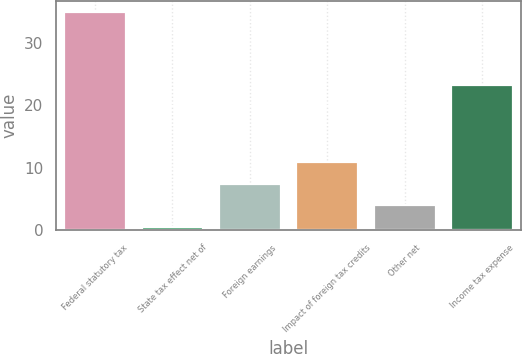<chart> <loc_0><loc_0><loc_500><loc_500><bar_chart><fcel>Federal statutory tax<fcel>State tax effect net of<fcel>Foreign earnings<fcel>Impact of foreign tax credits<fcel>Other net<fcel>Income tax expense<nl><fcel>35<fcel>0.5<fcel>7.4<fcel>10.85<fcel>3.95<fcel>23.2<nl></chart> 